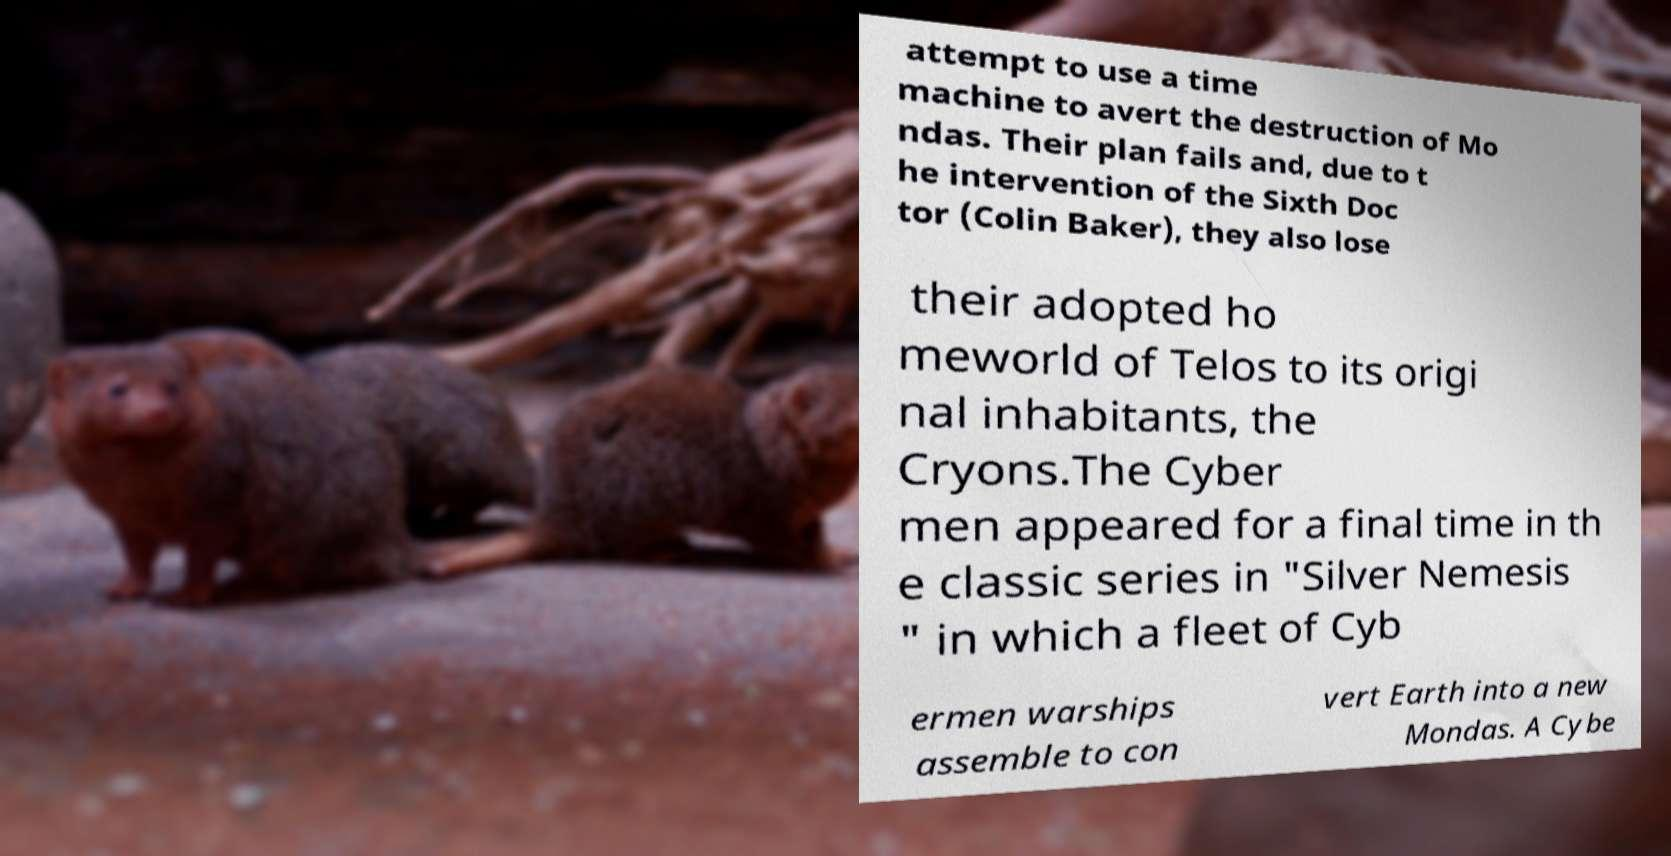Could you extract and type out the text from this image? attempt to use a time machine to avert the destruction of Mo ndas. Their plan fails and, due to t he intervention of the Sixth Doc tor (Colin Baker), they also lose their adopted ho meworld of Telos to its origi nal inhabitants, the Cryons.The Cyber men appeared for a final time in th e classic series in "Silver Nemesis " in which a fleet of Cyb ermen warships assemble to con vert Earth into a new Mondas. A Cybe 